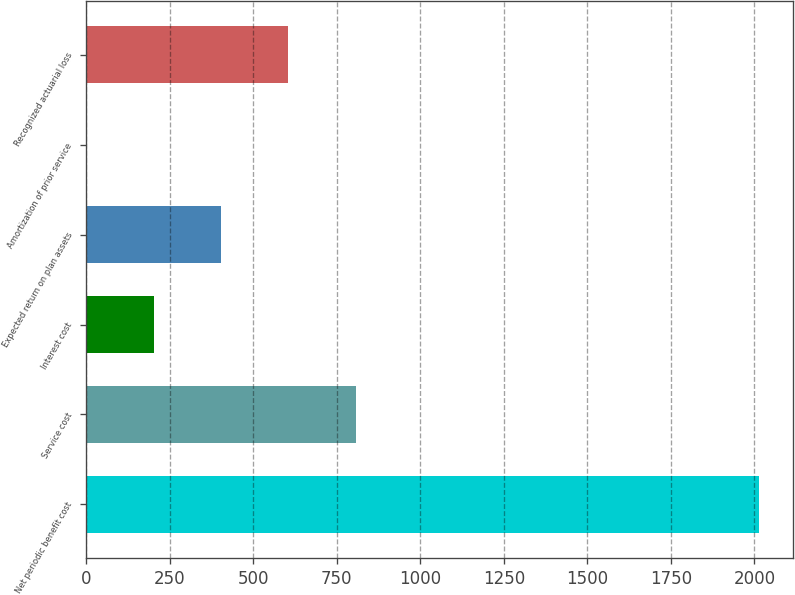Convert chart. <chart><loc_0><loc_0><loc_500><loc_500><bar_chart><fcel>Net periodic benefit cost<fcel>Service cost<fcel>Interest cost<fcel>Expected return on plan assets<fcel>Amortization of prior service<fcel>Recognized actuarial loss<nl><fcel>2015<fcel>806.6<fcel>202.4<fcel>403.8<fcel>1<fcel>605.2<nl></chart> 